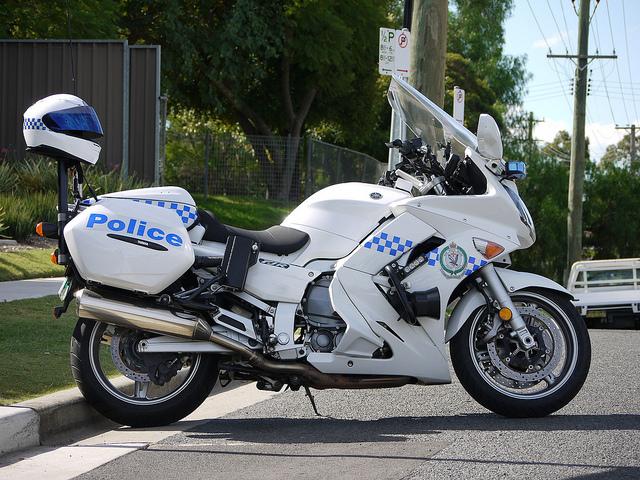What kind of person will be riding the bike?
Short answer required. Police. What kind of a sign is posted behind the pole?
Write a very short answer. No parking. What color is the bike?
Quick response, please. White. What colors are the bike?
Short answer required. White. Is the bike on a kickstand?
Quick response, please. Yes. Is the motorcycle moving or parked?
Quick response, please. Parked. What color is the motorcycle?
Concise answer only. White. What color is the helmet?
Concise answer only. White. What kind of tree is behind the motorcycle?
Answer briefly. Oak. Is there a helmet?
Keep it brief. Yes. How many bikes are in the photo?
Short answer required. 1. How many steps are there?
Be succinct. 0. 